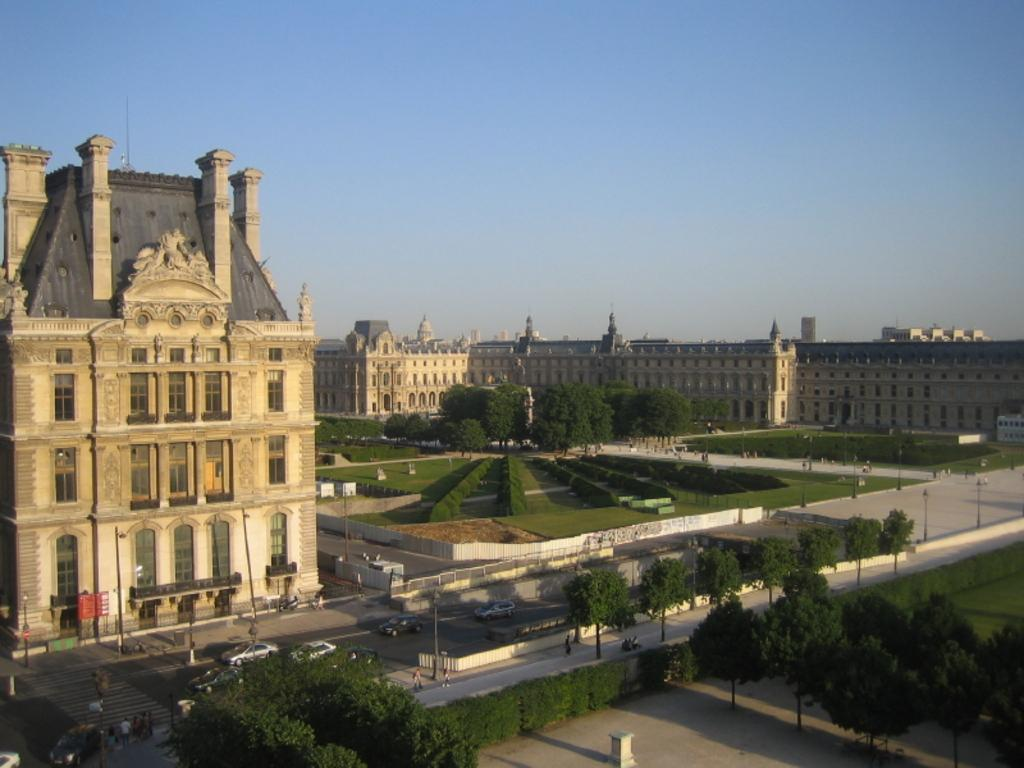What type of structures can be seen in the image? There are many buildings with windows in the image. What type of vegetation is present in the image? There are trees and bushes in the image. What type of street infrastructure is present in the image? There are light poles in the image. What type of transportation can be seen in the image? There is a road with vehicles in the image. What is visible in the background of the image? The sky is visible in the background of the image. What type of soup is being served in the image? There is no soup present in the image. Can you see any signs of an industry in the image? There is no specific reference to an industry in the image; it primarily features buildings, trees, bushes, light poles, vehicles, and the sky. 